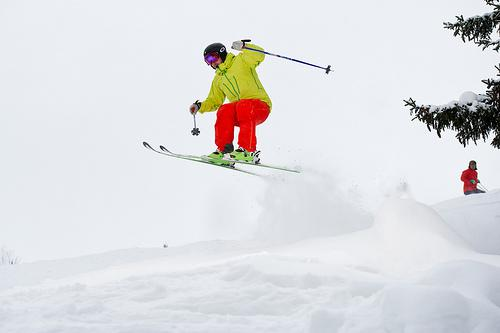Question: what is the color of the snow?
Choices:
A. White.
B. Off-white.
C. Gray.
D. Black.
Answer with the letter. Answer: A Question: where is the person on skis?
Choices:
A. Up in the air.
B. Tumbling down the hill.
C. Skiing on the slope.
D. In the lodge.
Answer with the letter. Answer: A Question: what is yellow?
Choices:
A. A person's jacket.
B. A toy cat.
C. The car.
D. His shirt.
Answer with the letter. Answer: A Question: what is green?
Choices:
A. His shirt.
B. The tree.
C. The car.
D. The building.
Answer with the letter. Answer: B Question: who is wearing orange pants?
Choices:
A. A scary clown.
B. The skier.
C. The referee.
D. A baby.
Answer with the letter. Answer: B 